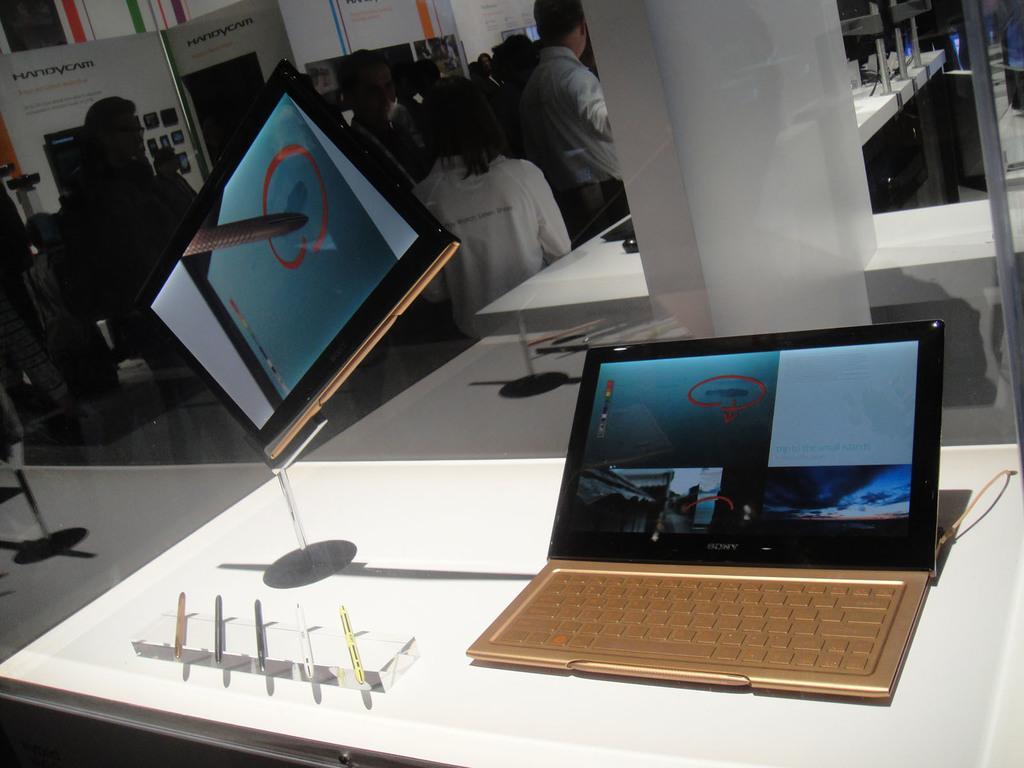Could you give a brief overview of what you see in this image? There is a laptop, a tablet and some pens placed on the table. In the background there are some people standing behind them there is a board. 